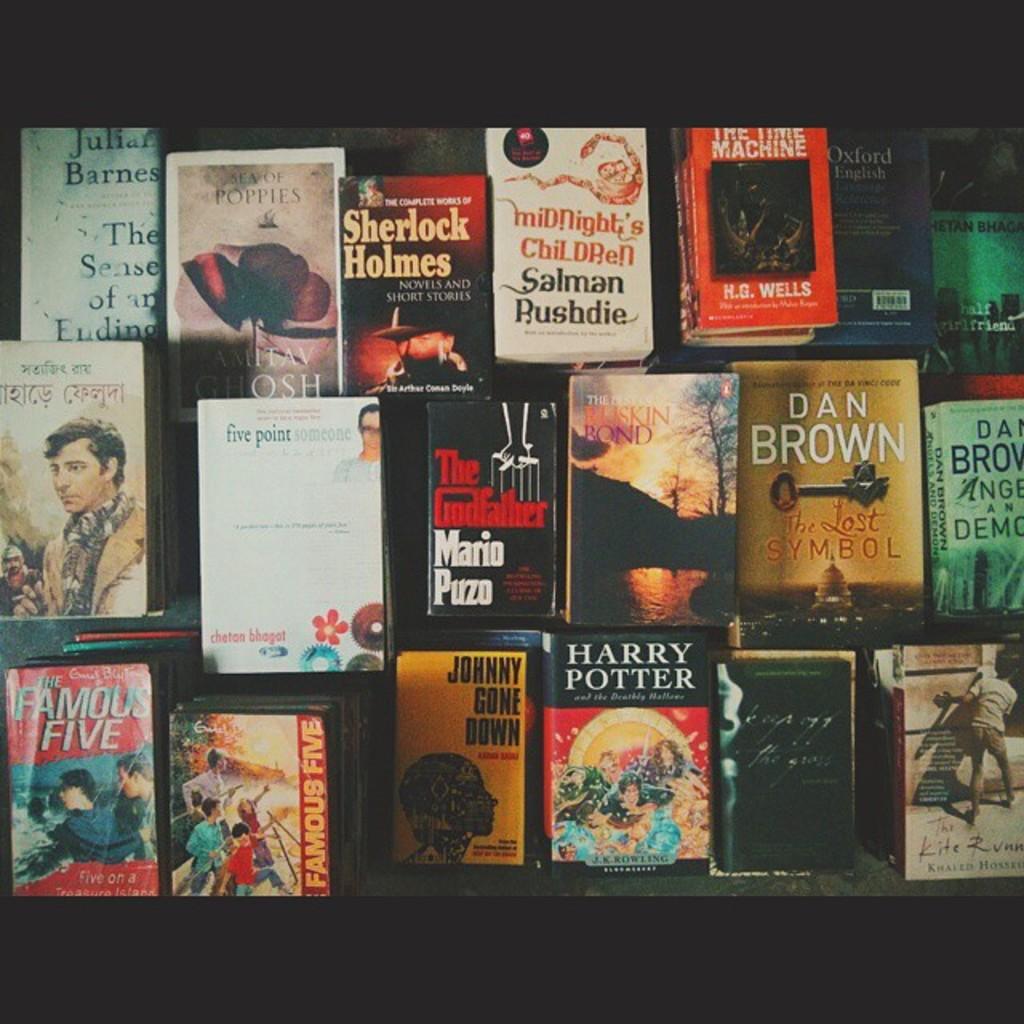What book is about a famous detective?
Provide a succinct answer. Sherlock holmes. What book is on the bottom left?
Keep it short and to the point. The famous five. 